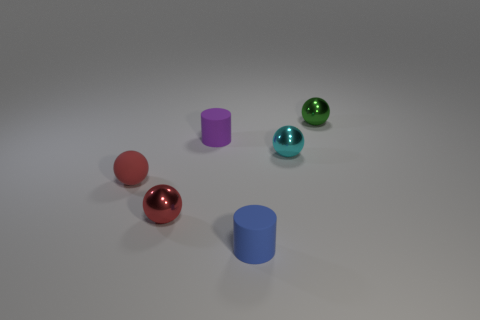Subtract all purple blocks. How many red spheres are left? 2 Subtract all small cyan spheres. How many spheres are left? 3 Add 4 tiny red matte objects. How many objects exist? 10 Subtract all cyan balls. How many balls are left? 3 Subtract all yellow spheres. Subtract all brown blocks. How many spheres are left? 4 Subtract all balls. How many objects are left? 2 Add 4 tiny red rubber objects. How many tiny red rubber objects are left? 5 Add 5 blue metal things. How many blue metal things exist? 5 Subtract 1 cyan spheres. How many objects are left? 5 Subtract all small matte cylinders. Subtract all large rubber spheres. How many objects are left? 4 